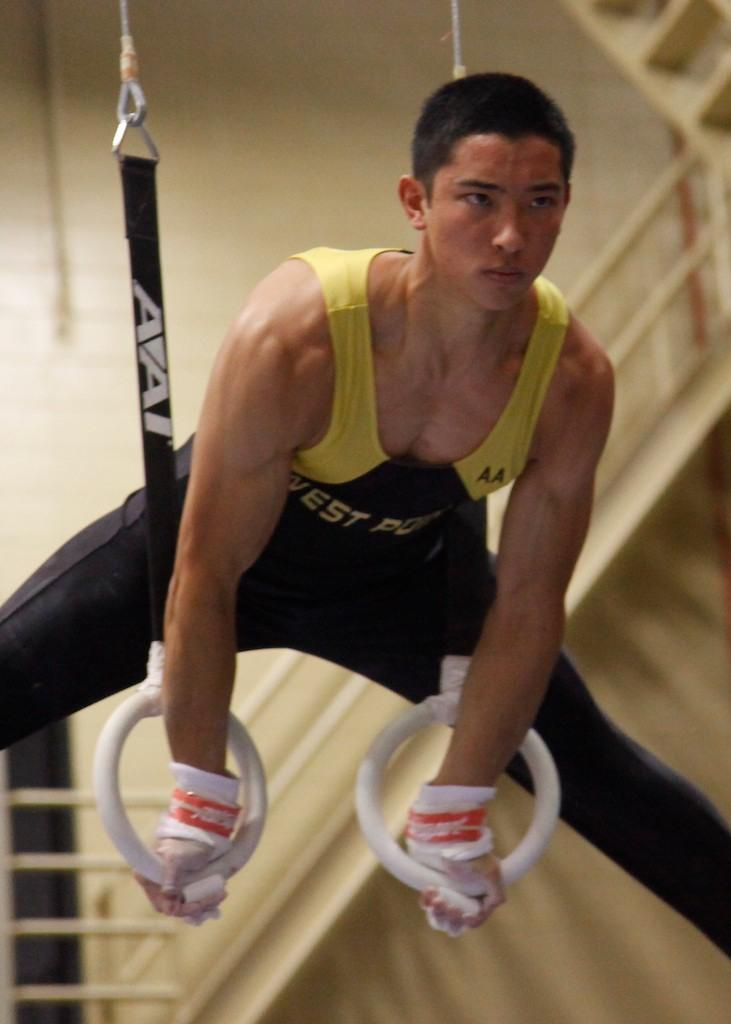<image>
Summarize the visual content of the image. A gymnast goes through is paces wearing a West Point black and yellow top 